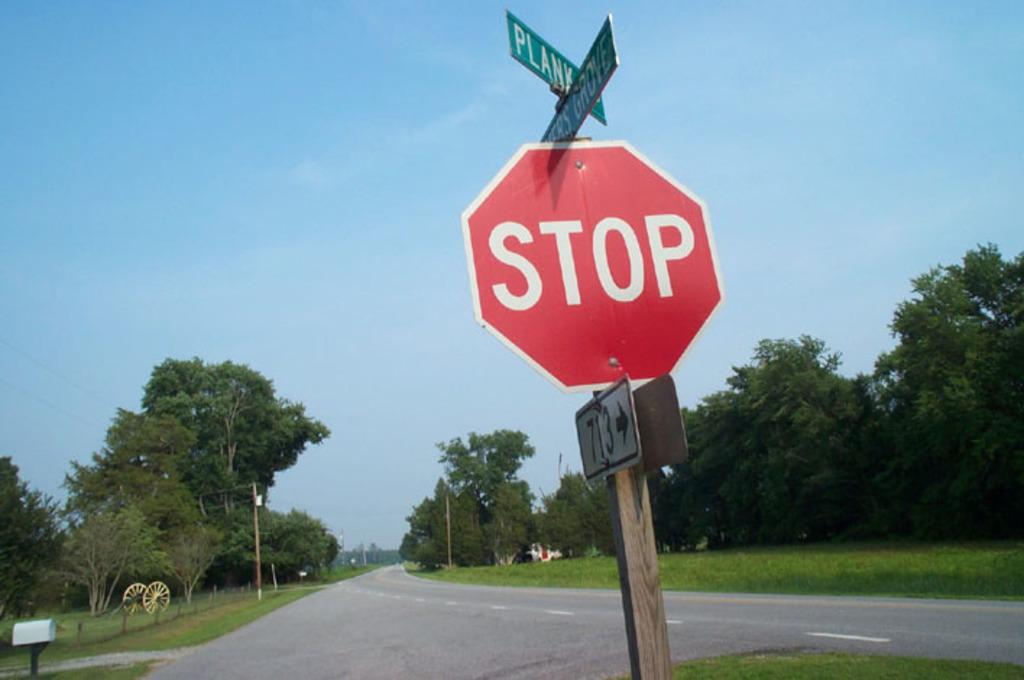Provide a one-sentence caption for the provided image. A red stop sign on an open road with trees in the background. 